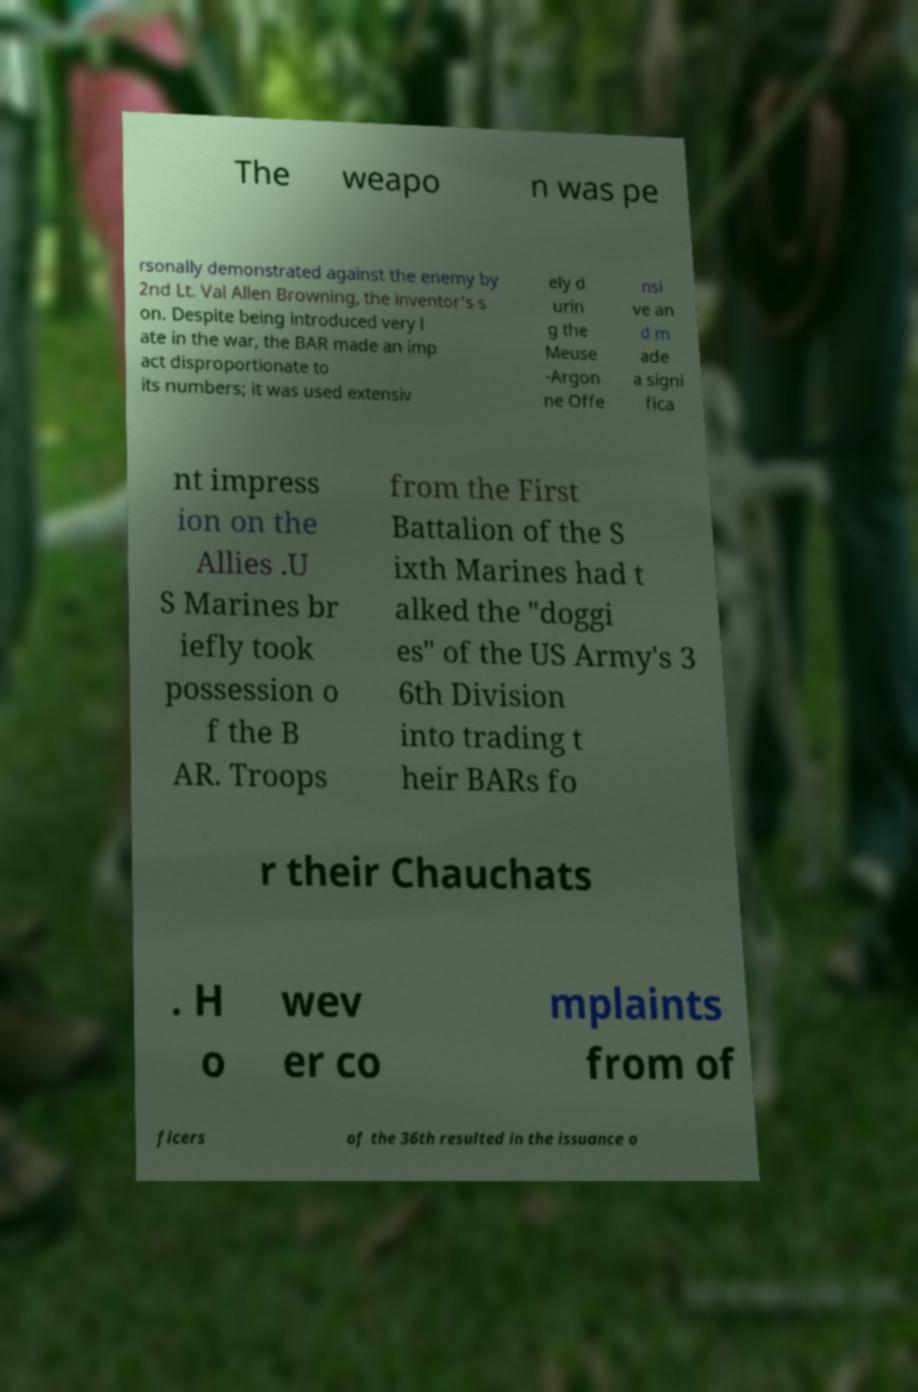Could you assist in decoding the text presented in this image and type it out clearly? The weapo n was pe rsonally demonstrated against the enemy by 2nd Lt. Val Allen Browning, the inventor's s on. Despite being introduced very l ate in the war, the BAR made an imp act disproportionate to its numbers; it was used extensiv ely d urin g the Meuse -Argon ne Offe nsi ve an d m ade a signi fica nt impress ion on the Allies .U S Marines br iefly took possession o f the B AR. Troops from the First Battalion of the S ixth Marines had t alked the "doggi es" of the US Army's 3 6th Division into trading t heir BARs fo r their Chauchats . H o wev er co mplaints from of ficers of the 36th resulted in the issuance o 